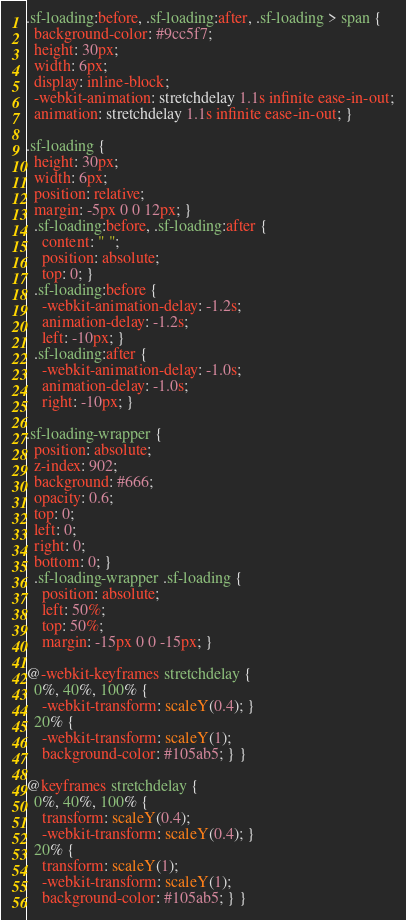<code> <loc_0><loc_0><loc_500><loc_500><_CSS_>.sf-loading:before, .sf-loading:after, .sf-loading > span {
  background-color: #9cc5f7;
  height: 30px;
  width: 6px;
  display: inline-block;
  -webkit-animation: stretchdelay 1.1s infinite ease-in-out;
  animation: stretchdelay 1.1s infinite ease-in-out; }

.sf-loading {
  height: 30px;
  width: 6px;
  position: relative;
  margin: -5px 0 0 12px; }
  .sf-loading:before, .sf-loading:after {
    content: " ";
    position: absolute;
    top: 0; }
  .sf-loading:before {
    -webkit-animation-delay: -1.2s;
    animation-delay: -1.2s;
    left: -10px; }
  .sf-loading:after {
    -webkit-animation-delay: -1.0s;
    animation-delay: -1.0s;
    right: -10px; }

.sf-loading-wrapper {
  position: absolute;
  z-index: 902;
  background: #666;
  opacity: 0.6;
  top: 0;
  left: 0;
  right: 0;
  bottom: 0; }
  .sf-loading-wrapper .sf-loading {
    position: absolute;
    left: 50%;
    top: 50%;
    margin: -15px 0 0 -15px; }

@-webkit-keyframes stretchdelay {
  0%, 40%, 100% {
    -webkit-transform: scaleY(0.4); }
  20% {
    -webkit-transform: scaleY(1);
    background-color: #105ab5; } }

@keyframes stretchdelay {
  0%, 40%, 100% {
    transform: scaleY(0.4);
    -webkit-transform: scaleY(0.4); }
  20% {
    transform: scaleY(1);
    -webkit-transform: scaleY(1);
    background-color: #105ab5; } }
</code> 